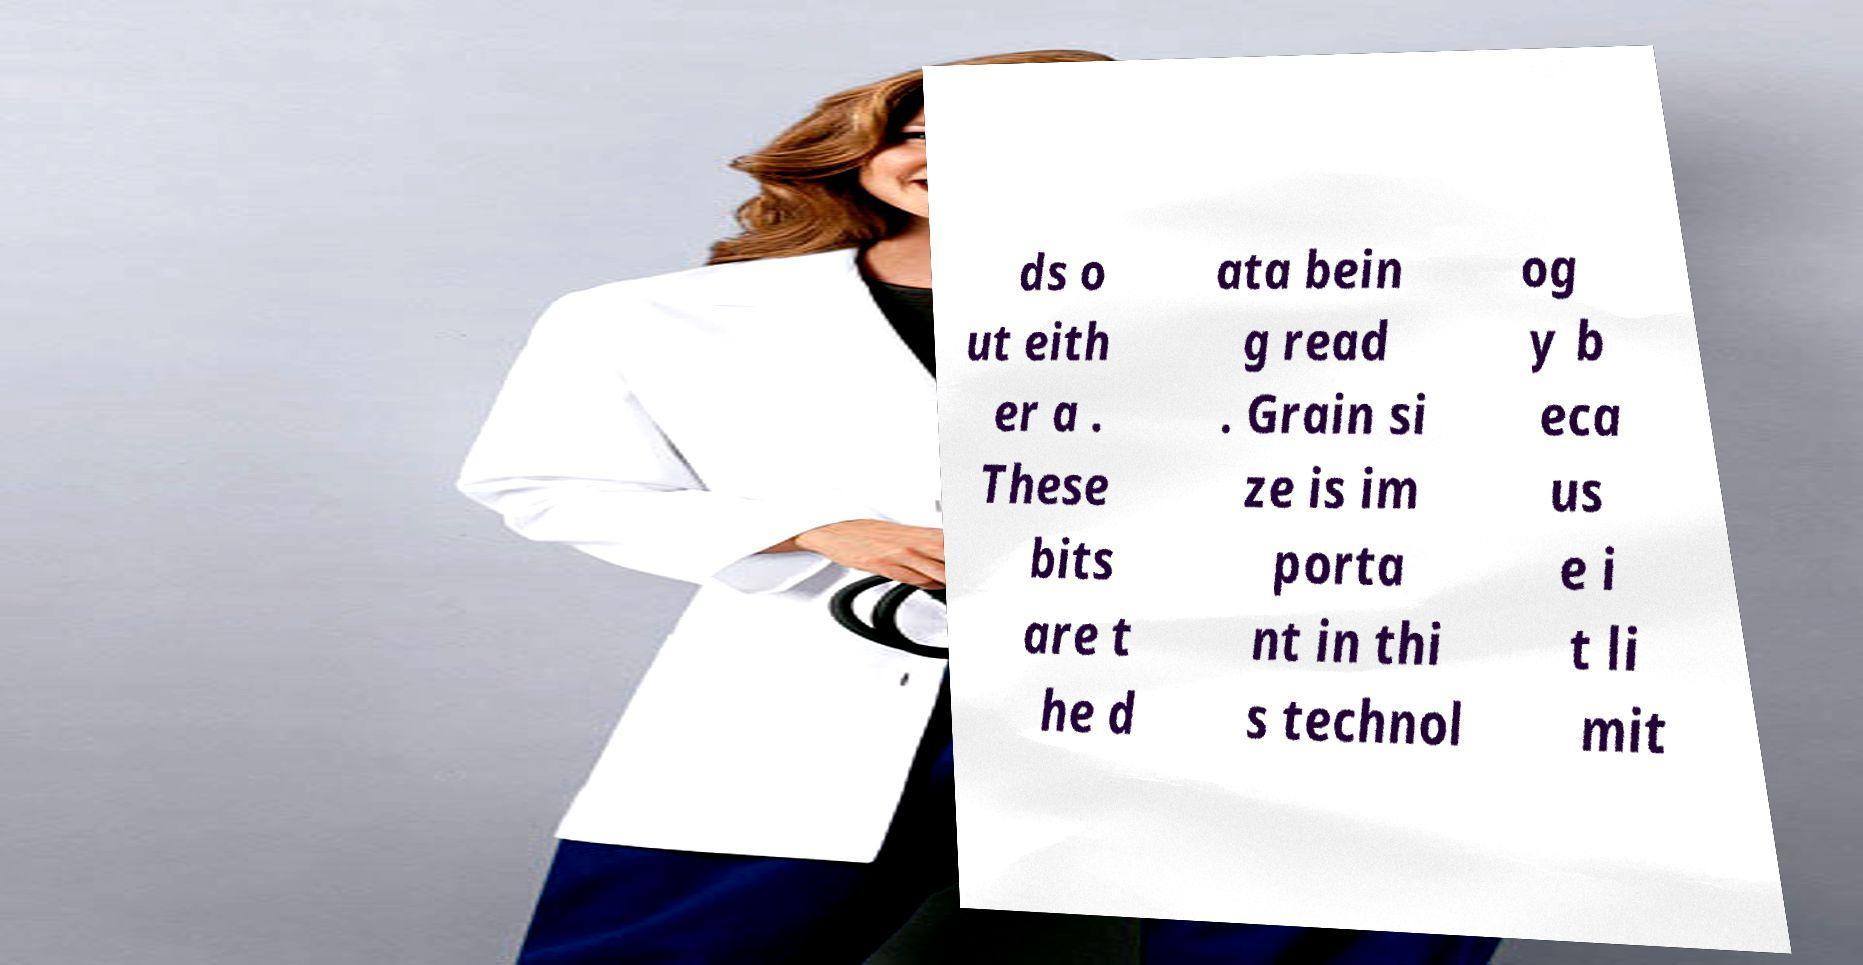Can you accurately transcribe the text from the provided image for me? ds o ut eith er a . These bits are t he d ata bein g read . Grain si ze is im porta nt in thi s technol og y b eca us e i t li mit 